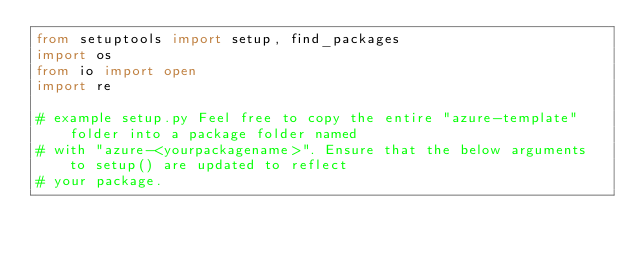<code> <loc_0><loc_0><loc_500><loc_500><_Python_>from setuptools import setup, find_packages
import os
from io import open
import re

# example setup.py Feel free to copy the entire "azure-template" folder into a package folder named
# with "azure-<yourpackagename>". Ensure that the below arguments to setup() are updated to reflect
# your package.
</code> 